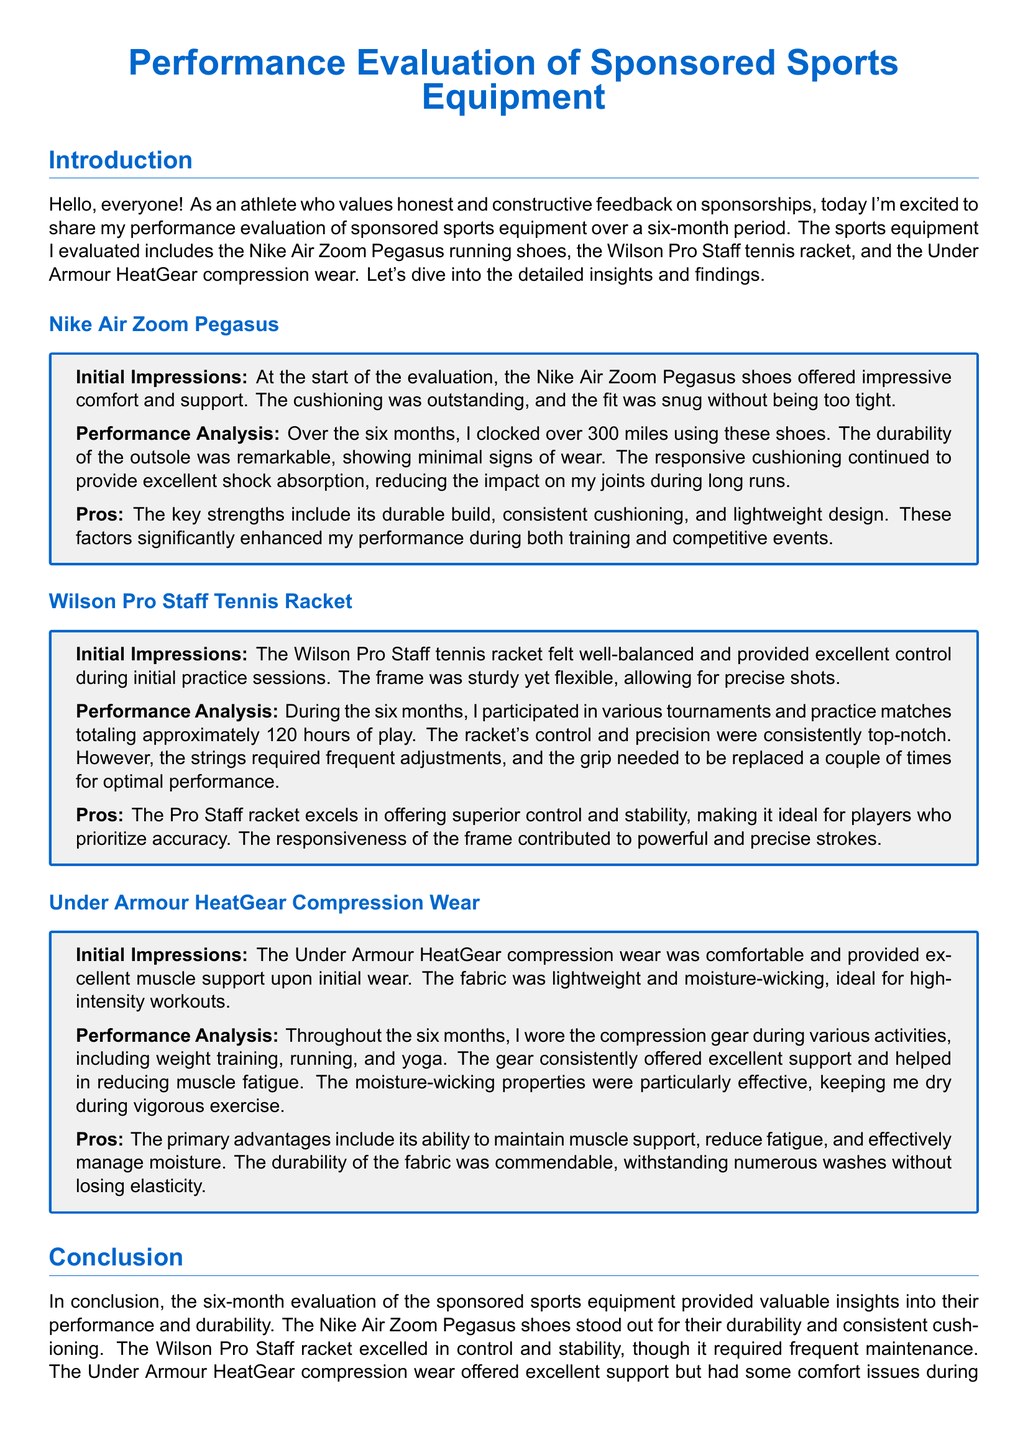what is the total distance covered with the Nike Air Zoom Pegasus? The total distance covered is mentioned in the document as over 300 miles.
Answer: over 300 miles how many hours of play did the Wilson Pro Staff tennis racket get? The document specifies that there were approximately 120 hours of play with the racket.
Answer: approximately 120 hours what are the primary advantages of the Under Armour HeatGear compression wear? The advantages are listed in the document as maintaining muscle support, reducing fatigue, and effectively managing moisture.
Answer: maintaining muscle support, reducing fatigue, and effectively managing moisture what was the initial impression of the Nike Air Zoom Pegasus shoes? The initial impression states that the shoes offered impressive comfort and support, with outstanding cushioning and a snug fit.
Answer: impressive comfort and support what issue did the Wilson Pro Staff tennis racket have during the evaluation period? The document mentions that the strings required frequent adjustments and the grip needed replacement a couple of times.
Answer: strings required frequent adjustments and grip needed replacement how long was the evaluation period for the sports equipment? The evaluation period mentioned in the document is six months.
Answer: six months what is the main characteristic of the Under Armour HeatGear compression wear fabric? The document describes the fabric as lightweight and moisture-wicking, which is ideal for high-intensity workouts.
Answer: lightweight and moisture-wicking which piece of equipment is noted for its durability during the evaluation? The Nike Air Zoom Pegasus shoes are specifically noted for their durability in the document.
Answer: Nike Air Zoom Pegasus shoes 